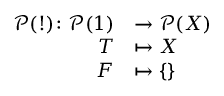<formula> <loc_0><loc_0><loc_500><loc_500>\begin{array} { r l } { { \mathcal { P } } ( ! ) \colon { \mathcal { P } } ( 1 ) } & { \to { \mathcal { P } } ( X ) } \\ { T } & { \mapsto X } \\ { F } & { \mapsto \{ \} } \end{array}</formula> 